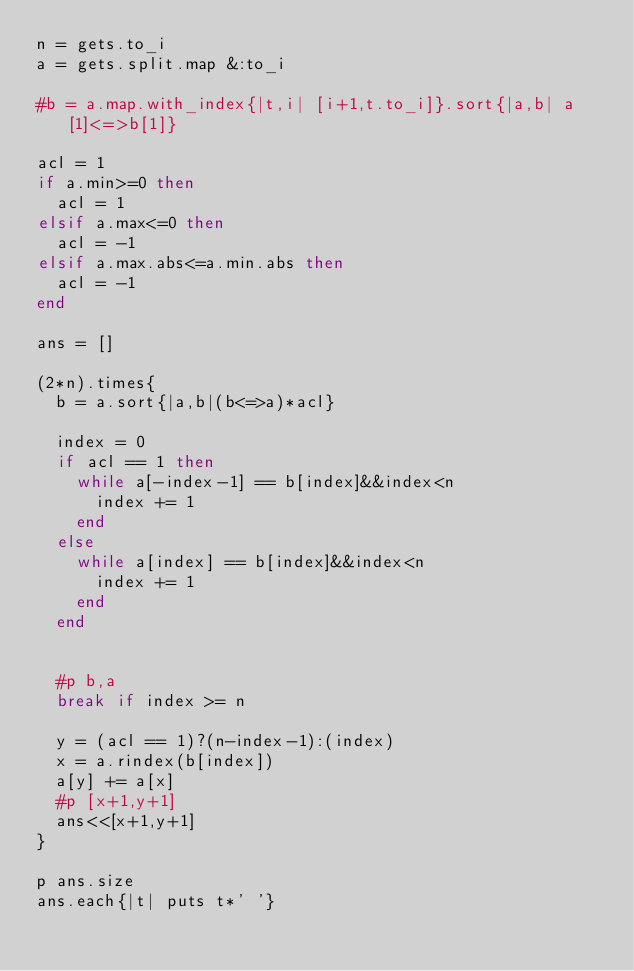Convert code to text. <code><loc_0><loc_0><loc_500><loc_500><_Ruby_>n = gets.to_i
a = gets.split.map &:to_i

#b = a.map.with_index{|t,i| [i+1,t.to_i]}.sort{|a,b| a[1]<=>b[1]}

acl = 1
if a.min>=0 then
  acl = 1
elsif a.max<=0 then
  acl = -1
elsif a.max.abs<=a.min.abs then
  acl = -1
end

ans = []

(2*n).times{
  b = a.sort{|a,b|(b<=>a)*acl}
  
  index = 0
  if acl == 1 then
    while a[-index-1] == b[index]&&index<n
      index += 1
    end
  else
    while a[index] == b[index]&&index<n
      index += 1
    end
  end
  
  
  #p b,a
  break if index >= n
  
  y = (acl == 1)?(n-index-1):(index)
  x = a.rindex(b[index])
  a[y] += a[x]
  #p [x+1,y+1]
  ans<<[x+1,y+1]
}

p ans.size
ans.each{|t| puts t*' '}

</code> 